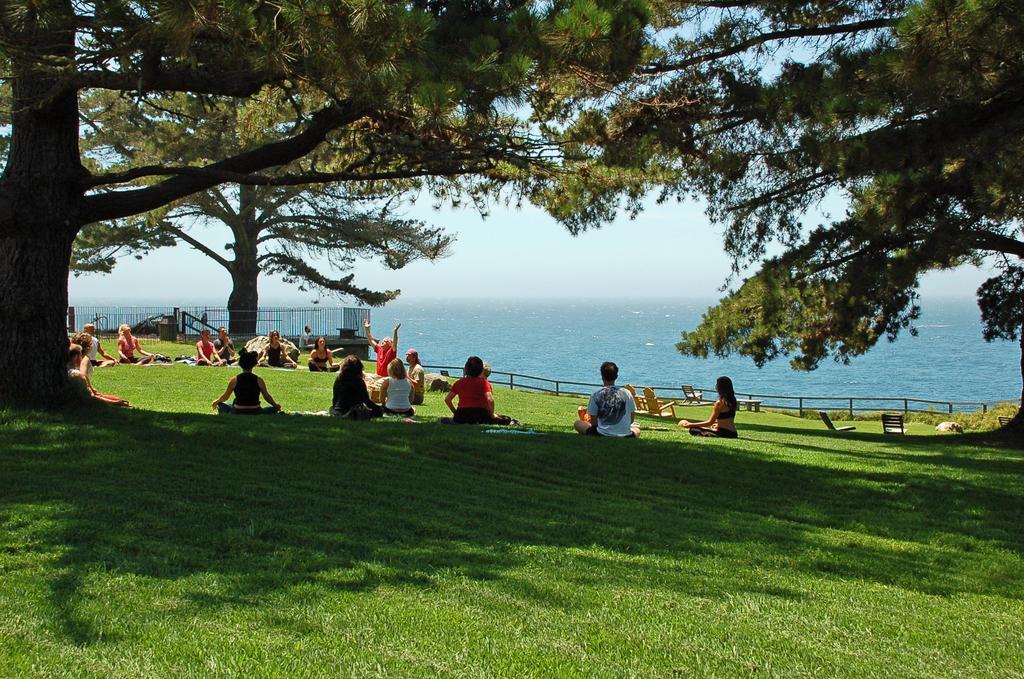Could you give a brief overview of what you see in this image? In this picture we can see some people are sitting on the ground and doing yoga. In the background of the image we can see the trees, grass, chairs, railing, grilles and clothes. In the middle of the image we can see the water and boats. At the top of the image we can see the sky. At the bottom of the image we can see the ground. 